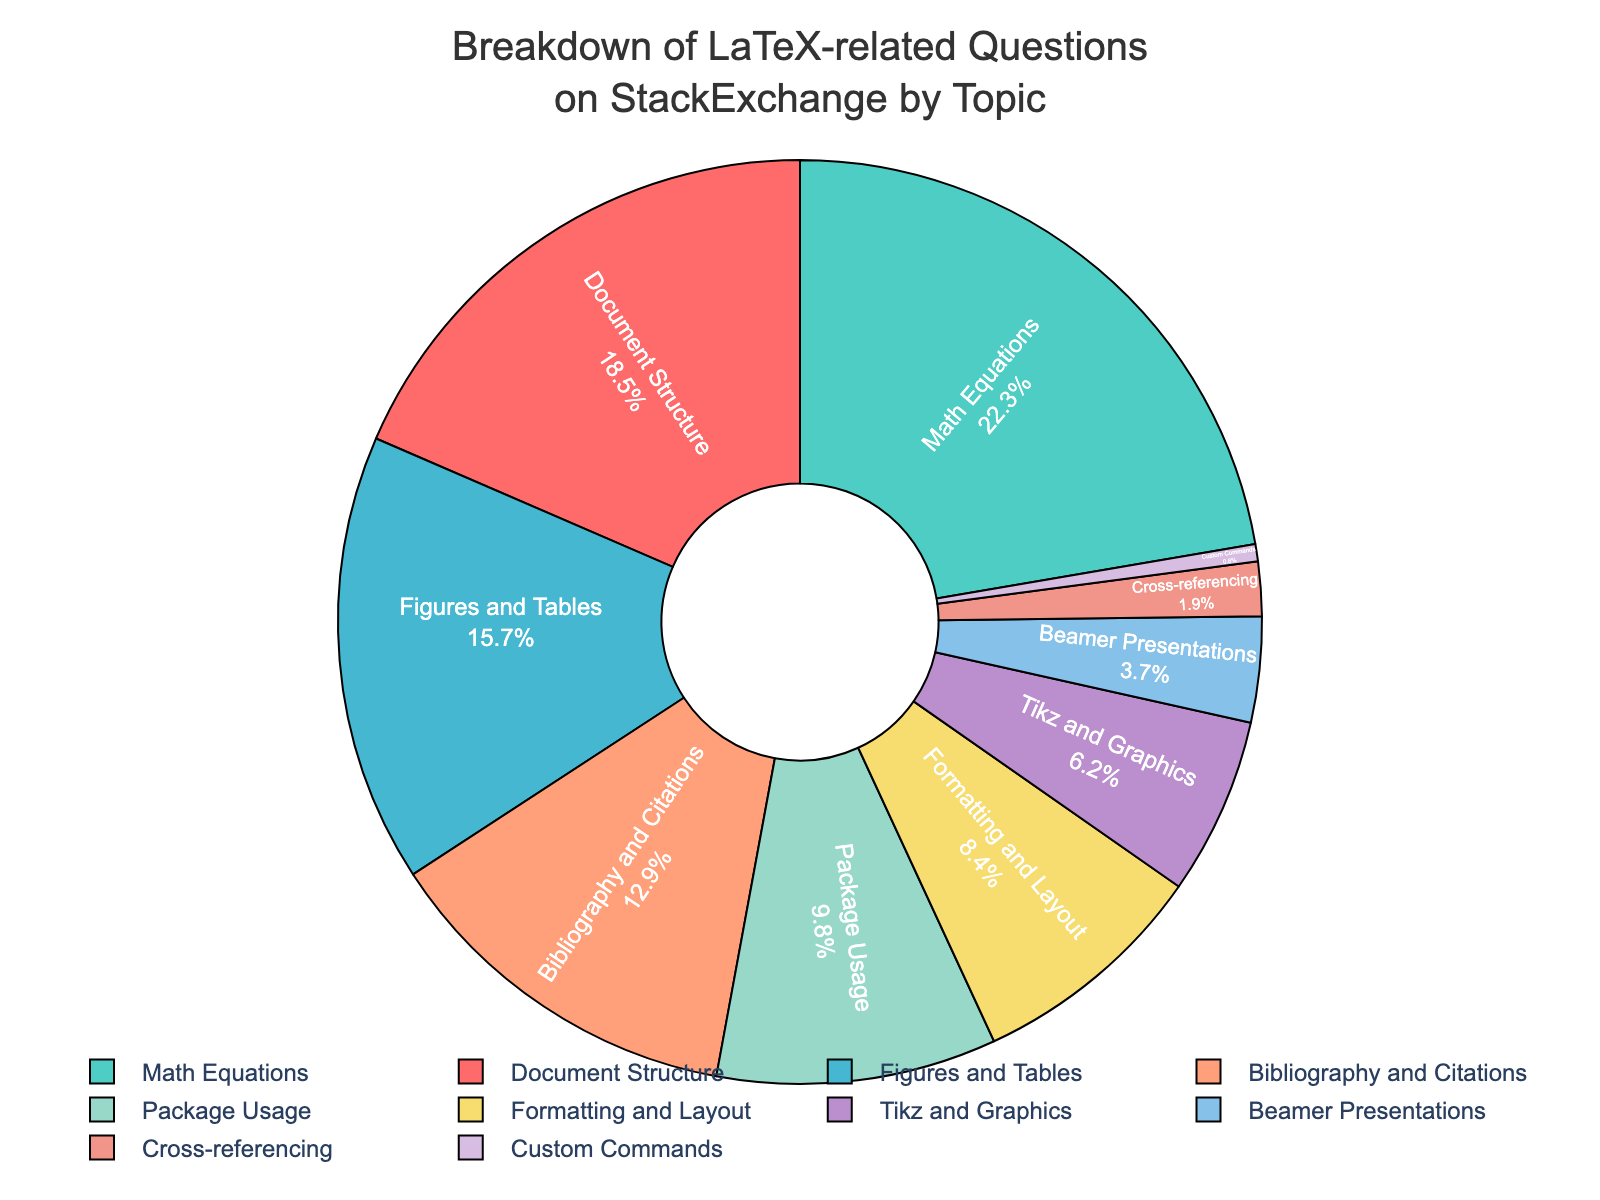Which topic has the highest percentage of LaTeX-related questions? The figure shows the percentage of questions per topic clearly. The topic with the largest portion of the pie is Math Equations.
Answer: Math Equations What is the combined percentage of questions for "Figures and Tables" and "Bibliography and Citations"? To find the combined percentage, add the percentages for "Figures and Tables" (15.7%) and "Bibliography and Citations" (12.9%). Therefore, 15.7% + 12.9% = 28.6%.
Answer: 28.6% Which topic has a smaller percentage, "Package Usage" or "Formatting and Layout"? By comparing the two slices in the pie chart, "Package Usage" has a percentage of 9.8% and "Formatting and Layout" has 8.4%. Since 8.4% is less than 9.8%, "Formatting and Layout" has a smaller percentage.
Answer: Formatting and Layout What is the percentage difference between "Document Structure" and "Beamer Presentations"? The difference can be calculated by subtracting the percentage of "Beamer Presentations" (3.7%) from "Document Structure" (18.5%). Thus, 18.5% - 3.7% = 14.8%.
Answer: 14.8% How many topics have a percentage less than 10%? The pie chart shows slices for each topic with their respective percentages. Count the topics with percentages less than 10%: Package Usage (9.8%), Formatting and Layout (8.4%), Tikz and Graphics (6.2%), Beamer Presentations (3.7%), Cross-referencing (1.9%), and Custom Commands (0.6%). There are six such topics.
Answer: 6 Which topic has the second-largest percentage of LaTeX-related questions? The largest percentage is for Math Equations (22.3%), so we need to find the second largest. The next largest percentage is for Document Structure (18.5%).
Answer: Document Structure Is the percentage of questions related to "Tikz and Graphics" higher than for "Beamer Presentations"? By comparing the slices, "Tikz and Graphics" has 6.2% while "Beamer Presentations" has 3.7%. Since 6.2% is greater than 3.7%, "Tikz and Graphics" indeed has a higher percentage.
Answer: Yes 